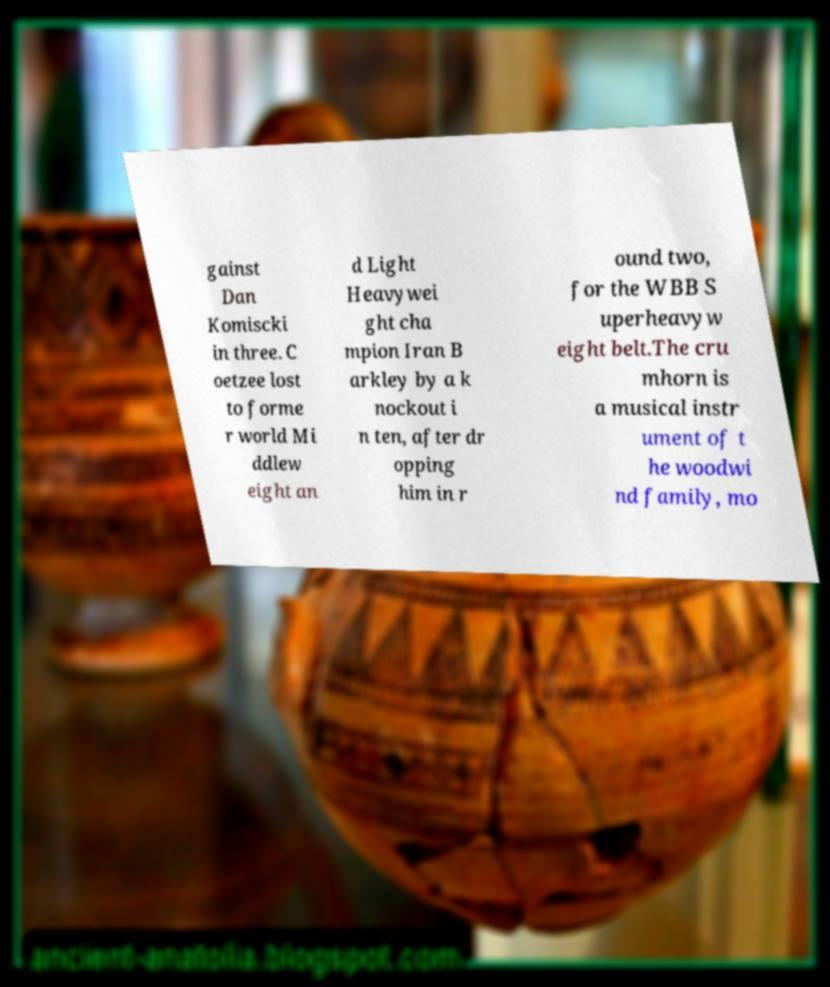Can you accurately transcribe the text from the provided image for me? gainst Dan Komiscki in three. C oetzee lost to forme r world Mi ddlew eight an d Light Heavywei ght cha mpion Iran B arkley by a k nockout i n ten, after dr opping him in r ound two, for the WBB S uperheavyw eight belt.The cru mhorn is a musical instr ument of t he woodwi nd family, mo 